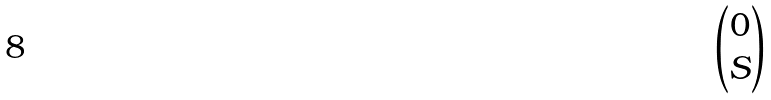Convert formula to latex. <formula><loc_0><loc_0><loc_500><loc_500>\begin{pmatrix} 0 \\ S \end{pmatrix}</formula> 